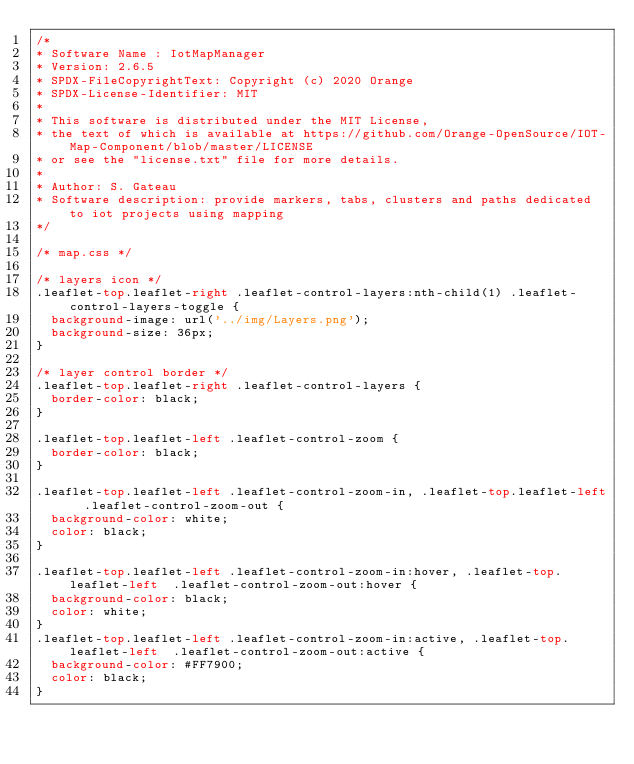<code> <loc_0><loc_0><loc_500><loc_500><_CSS_>/*
* Software Name : IotMapManager
* Version: 2.6.5
* SPDX-FileCopyrightText: Copyright (c) 2020 Orange
* SPDX-License-Identifier: MIT
*
* This software is distributed under the MIT License,
* the text of which is available at https://github.com/Orange-OpenSource/IOT-Map-Component/blob/master/LICENSE
* or see the "license.txt" file for more details.
*
* Author: S. Gateau
* Software description: provide markers, tabs, clusters and paths dedicated to iot projects using mapping
*/

/* map.css */

/* layers icon */
.leaflet-top.leaflet-right .leaflet-control-layers:nth-child(1) .leaflet-control-layers-toggle {
  background-image: url('../img/Layers.png');
  background-size: 36px;
}

/* layer control border */
.leaflet-top.leaflet-right .leaflet-control-layers {
  border-color: black;
}

.leaflet-top.leaflet-left .leaflet-control-zoom {
  border-color: black;
}

.leaflet-top.leaflet-left .leaflet-control-zoom-in, .leaflet-top.leaflet-left  .leaflet-control-zoom-out {
  background-color: white;
  color: black;
}

.leaflet-top.leaflet-left .leaflet-control-zoom-in:hover, .leaflet-top.leaflet-left  .leaflet-control-zoom-out:hover {
  background-color: black;
  color: white;
}
.leaflet-top.leaflet-left .leaflet-control-zoom-in:active, .leaflet-top.leaflet-left  .leaflet-control-zoom-out:active {
  background-color: #FF7900;
  color: black;
}


</code> 